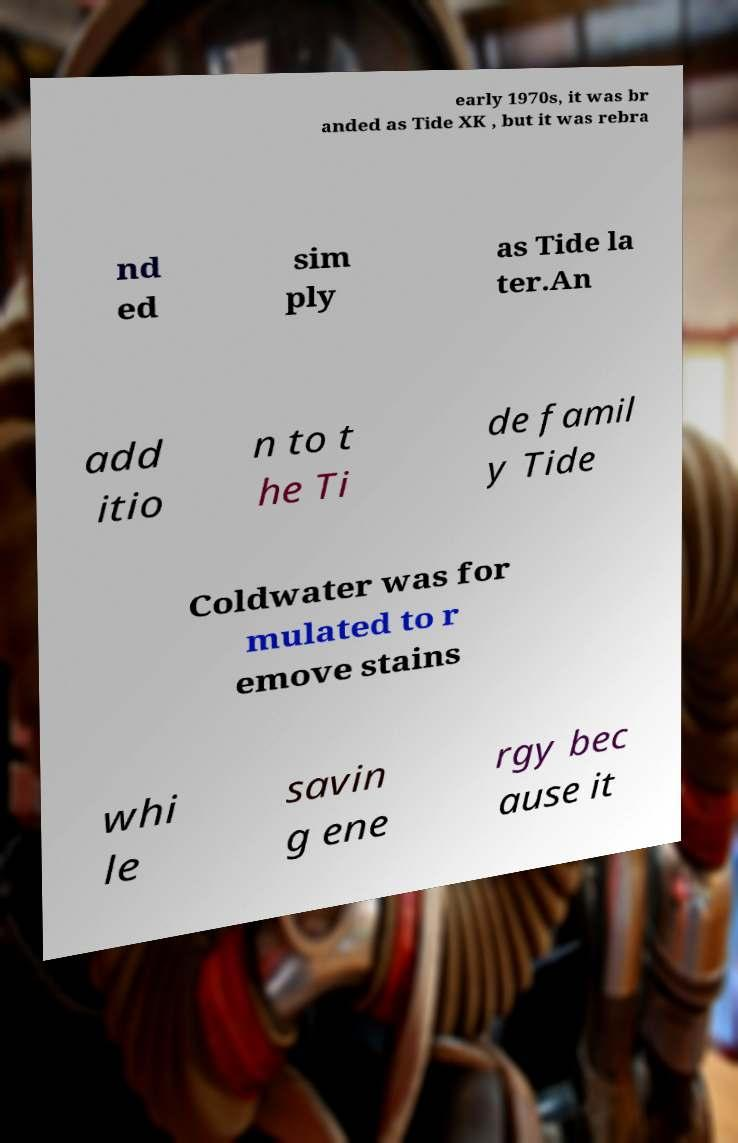Please read and relay the text visible in this image. What does it say? early 1970s, it was br anded as Tide XK , but it was rebra nd ed sim ply as Tide la ter.An add itio n to t he Ti de famil y Tide Coldwater was for mulated to r emove stains whi le savin g ene rgy bec ause it 